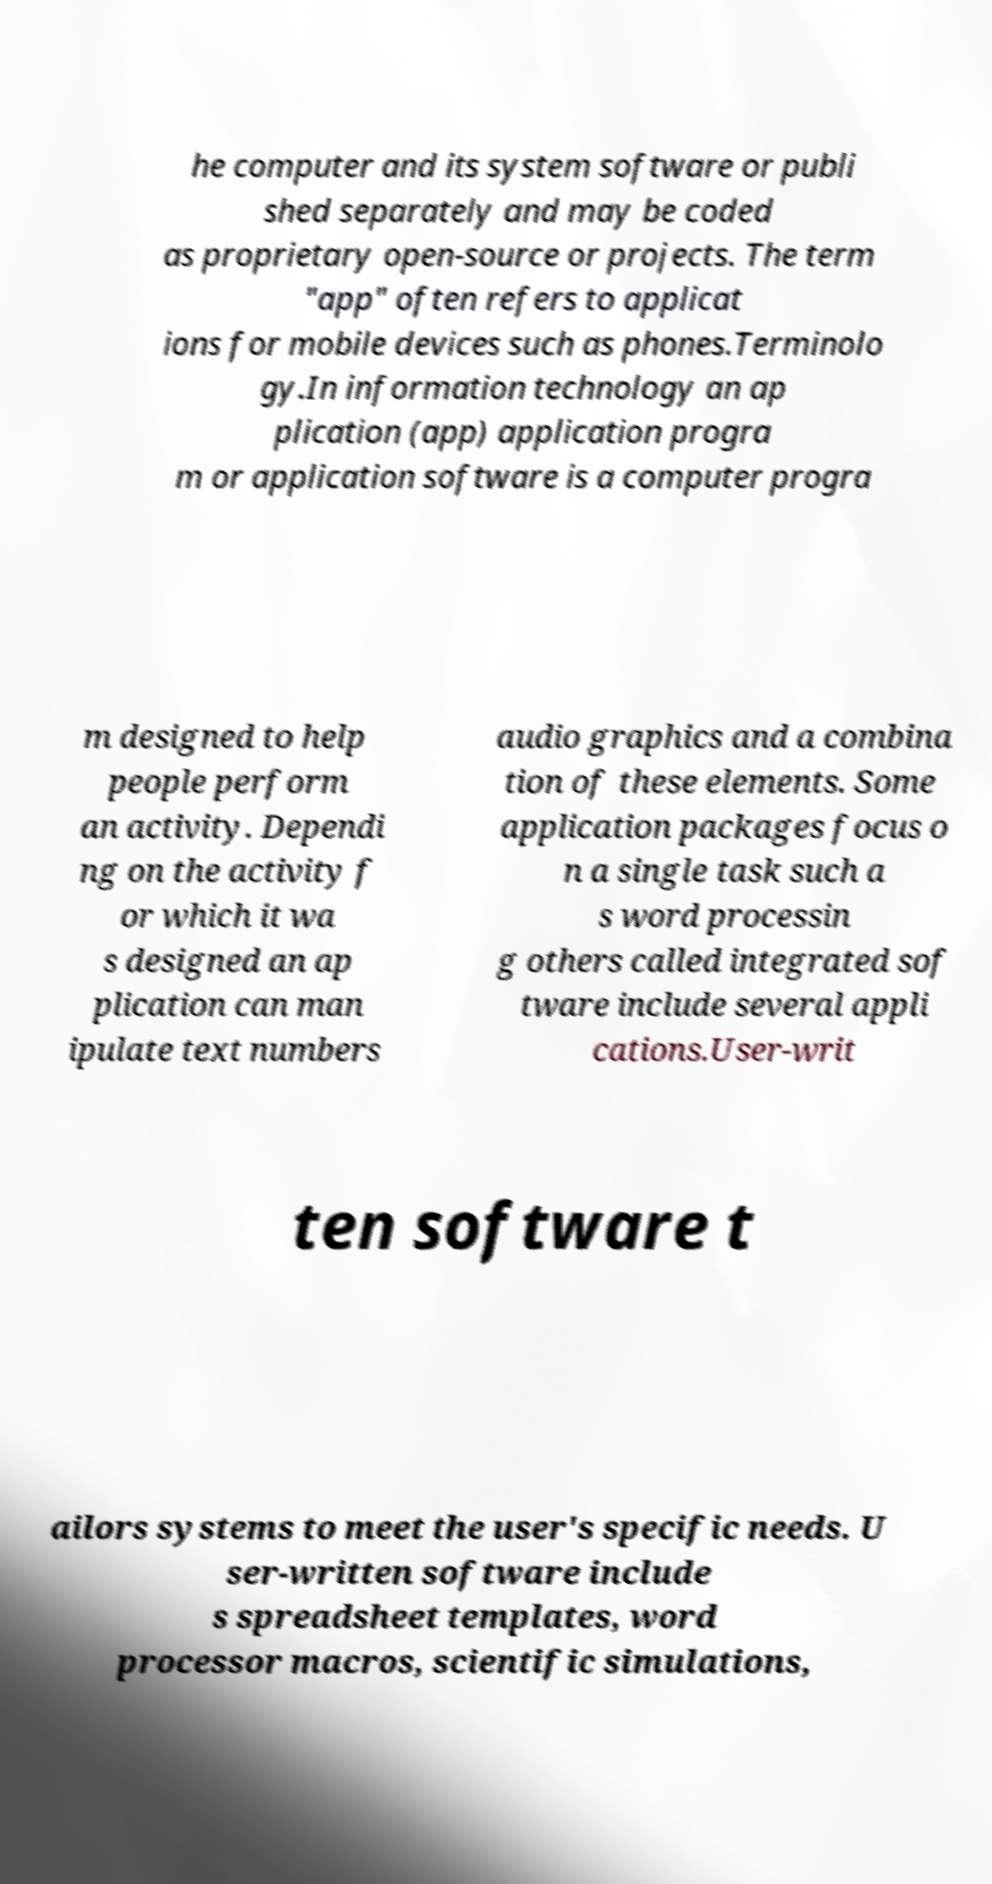There's text embedded in this image that I need extracted. Can you transcribe it verbatim? he computer and its system software or publi shed separately and may be coded as proprietary open-source or projects. The term "app" often refers to applicat ions for mobile devices such as phones.Terminolo gy.In information technology an ap plication (app) application progra m or application software is a computer progra m designed to help people perform an activity. Dependi ng on the activity f or which it wa s designed an ap plication can man ipulate text numbers audio graphics and a combina tion of these elements. Some application packages focus o n a single task such a s word processin g others called integrated sof tware include several appli cations.User-writ ten software t ailors systems to meet the user's specific needs. U ser-written software include s spreadsheet templates, word processor macros, scientific simulations, 